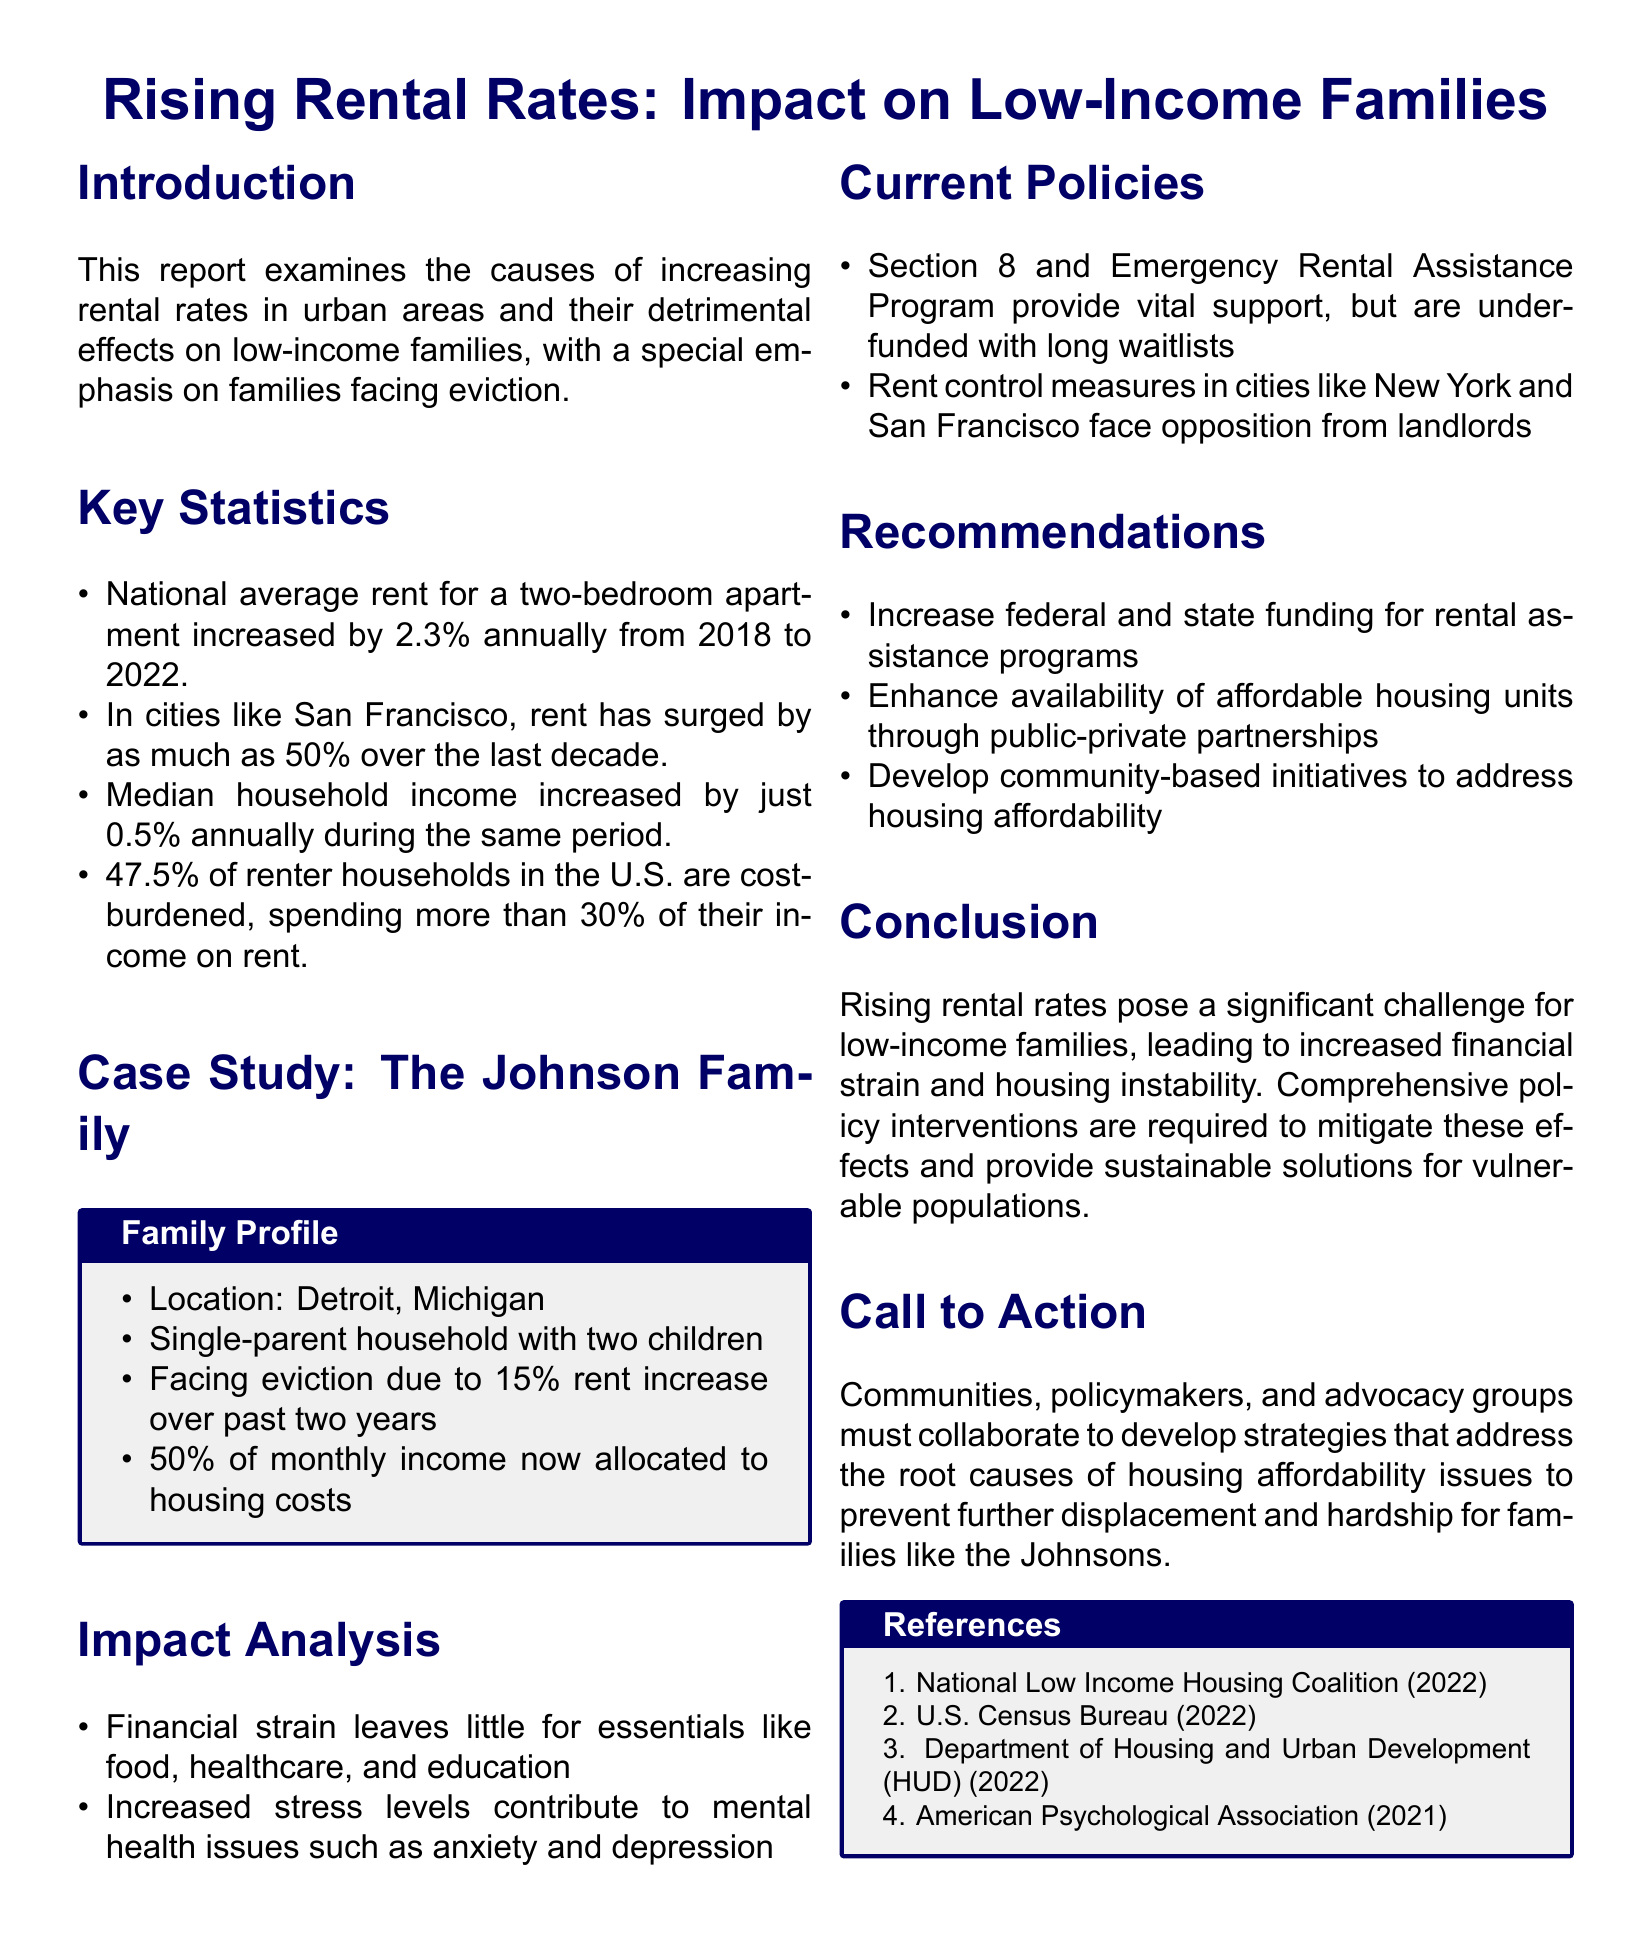What is the annual increase rate of the national average rent for a two-bedroom apartment? The national average rent for a two-bedroom apartment increased by 2.3% annually from 2018 to 2022.
Answer: 2.3% What percentage of renter households are cost-burdened? The document states that 47.5% of renter households in the U.S. are cost-burdened, spending more than 30% of their income on rent.
Answer: 47.5% How much has rent surged in cities like San Francisco over the last decade? The document indicates that rent has surged by as much as 50% over the last decade in cities like San Francisco.
Answer: 50% What percentage of the Johnson family's income is now allocated to housing costs? The Johnson family now allocates 50% of their monthly income to housing costs.
Answer: 50% What are the mental health issues increased by financial strain according to the report? Increased stress levels contribute to mental health issues such as anxiety and depression.
Answer: anxiety and depression What policy program is mentioned as providing vital support to families? The Section 8 and Emergency Rental Assistance Program are mentioned as vital support.
Answer: Section 8 and Emergency Rental Assistance Program What is one recommendation made in the report to address housing affordability? The report recommends increasing federal and state funding for rental assistance programs.
Answer: Increase federal and state funding for rental assistance programs Which city is highlighted in the case study of a low-income family? The Johnson family is located in Detroit, Michigan.
Answer: Detroit, Michigan What is the conclusion drawn about rising rental rates? The conclusion states that rising rental rates pose a significant challenge for low-income families.
Answer: significant challenge for low-income families 